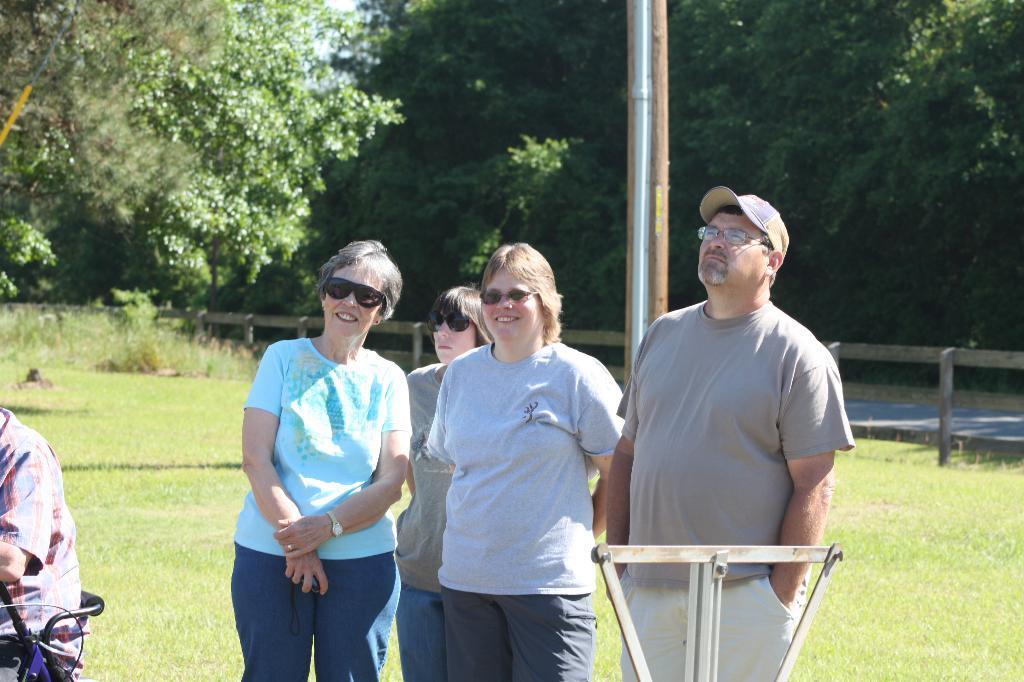How would you summarize this image in a sentence or two? In this image we can see a group of people are standing on the ground, and smiling, here is the grass, here is the pole, here is the fencing, here are the trees, at above here is the sky. 